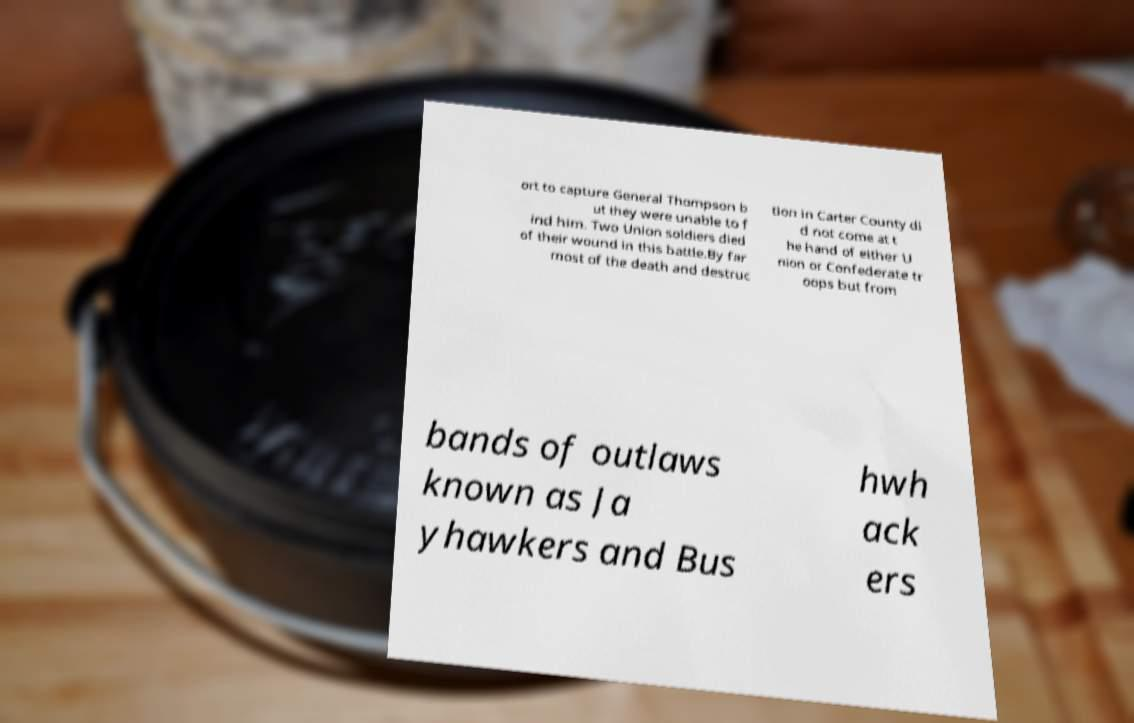Please read and relay the text visible in this image. What does it say? ort to capture General Thompson b ut they were unable to f ind him. Two Union soldiers died of their wound in this battle.By far most of the death and destruc tion in Carter County di d not come at t he hand of either U nion or Confederate tr oops but from bands of outlaws known as Ja yhawkers and Bus hwh ack ers 